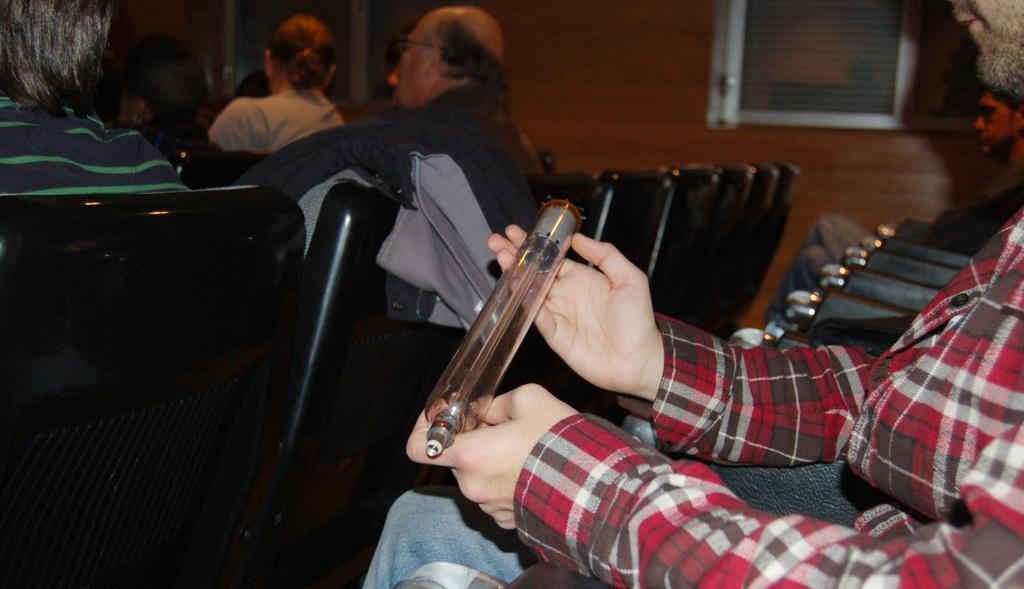What type of furniture is visible in the image? There are chairs in the image. What are the people in the image doing? People are sitting in cars. What can be seen in the background of the image? There are windows and a wall in the background of the image. How would you describe the background of the image? The background is blurred. What grade is the division being taught in the image? There is no indication of a division or grade being taught in the image. What type of sun can be seen in the image? There is no sun visible in the image. 